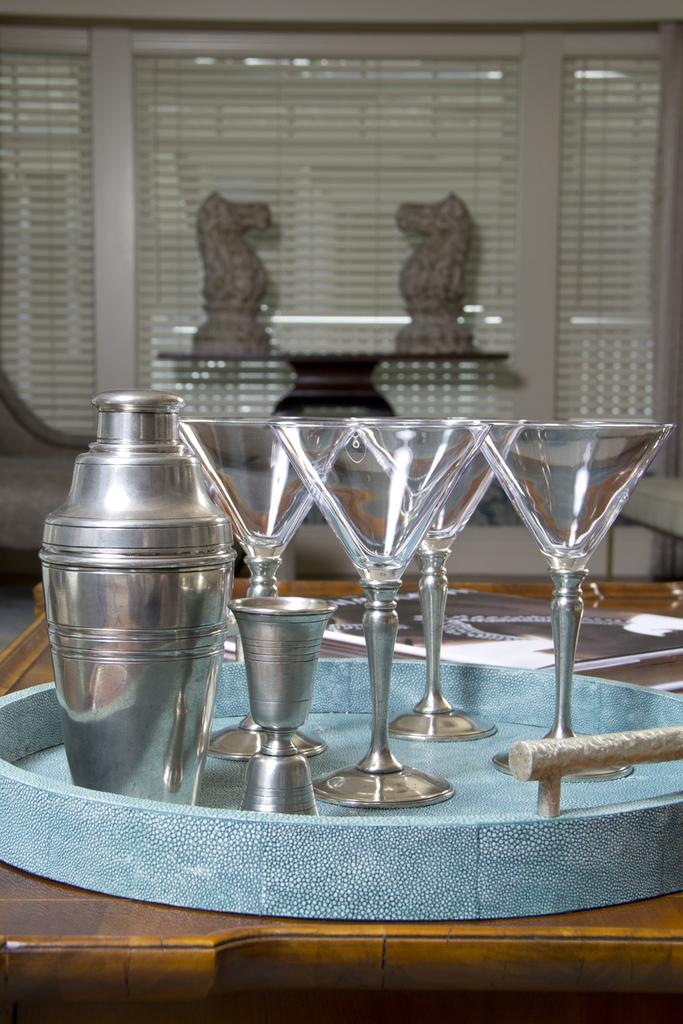What type of location is depicted in the image? The image shows the inside of a house. What can be seen on the table in the image? There are drink glasses on the table in the image. What other objects are present in the image besides the drink glasses? There are other objects in the image, but their specific details are not mentioned in the provided facts. What piece of furniture is visible in the image? There is a table in the image. What type of bomb is being traded in the image? There is no mention of a bomb or any trading activity in the image. The image depicts the inside of a house with drink glasses on a table. 